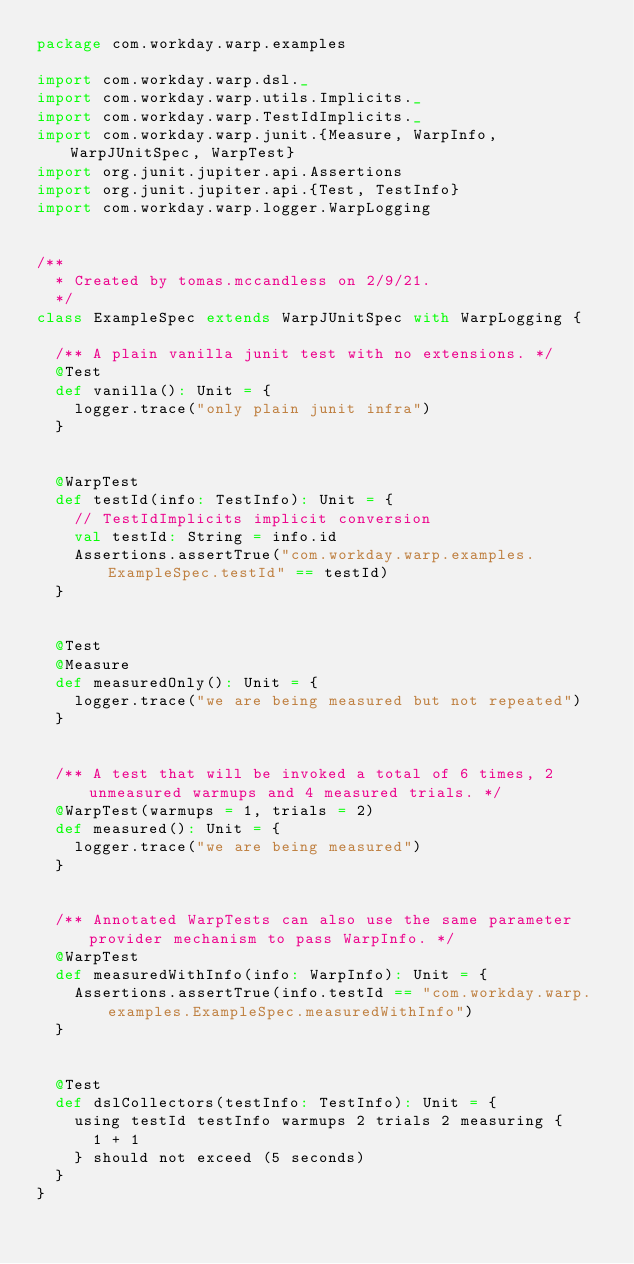Convert code to text. <code><loc_0><loc_0><loc_500><loc_500><_Scala_>package com.workday.warp.examples

import com.workday.warp.dsl._
import com.workday.warp.utils.Implicits._
import com.workday.warp.TestIdImplicits._
import com.workday.warp.junit.{Measure, WarpInfo, WarpJUnitSpec, WarpTest}
import org.junit.jupiter.api.Assertions
import org.junit.jupiter.api.{Test, TestInfo}
import com.workday.warp.logger.WarpLogging


/**
  * Created by tomas.mccandless on 2/9/21.
  */
class ExampleSpec extends WarpJUnitSpec with WarpLogging {

  /** A plain vanilla junit test with no extensions. */
  @Test
  def vanilla(): Unit = {
    logger.trace("only plain junit infra")
  }


  @WarpTest
  def testId(info: TestInfo): Unit = {
    // TestIdImplicits implicit conversion
    val testId: String = info.id
    Assertions.assertTrue("com.workday.warp.examples.ExampleSpec.testId" == testId)
  }


  @Test
  @Measure
  def measuredOnly(): Unit = {
    logger.trace("we are being measured but not repeated")
  }


  /** A test that will be invoked a total of 6 times, 2 unmeasured warmups and 4 measured trials. */
  @WarpTest(warmups = 1, trials = 2)
  def measured(): Unit = {
    logger.trace("we are being measured")
  }


  /** Annotated WarpTests can also use the same parameter provider mechanism to pass WarpInfo. */
  @WarpTest
  def measuredWithInfo(info: WarpInfo): Unit = {
    Assertions.assertTrue(info.testId == "com.workday.warp.examples.ExampleSpec.measuredWithInfo")
  }


  @Test
  def dslCollectors(testInfo: TestInfo): Unit = {
    using testId testInfo warmups 2 trials 2 measuring {
      1 + 1
    } should not exceed (5 seconds)
  }
}
</code> 